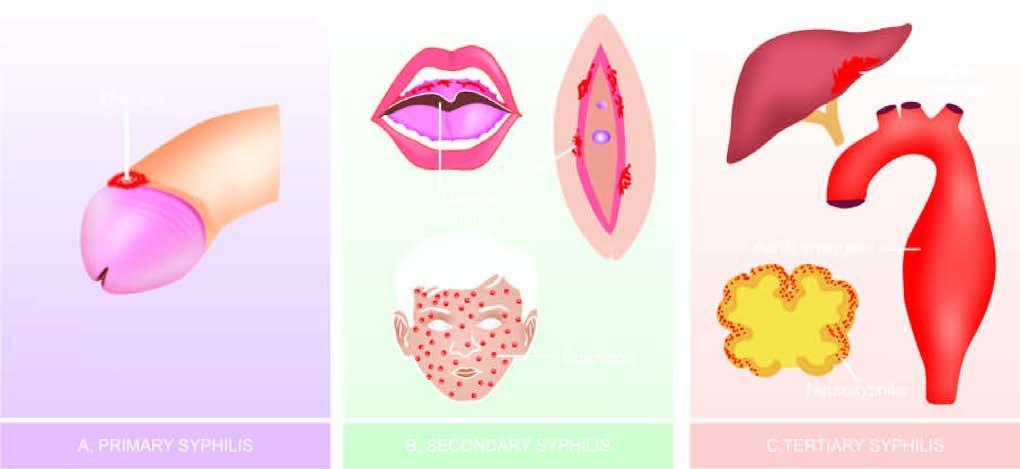s primary syphilis: primary lesion 'chancre ' on glans penis?
Answer the question using a single word or phrase. Yes 